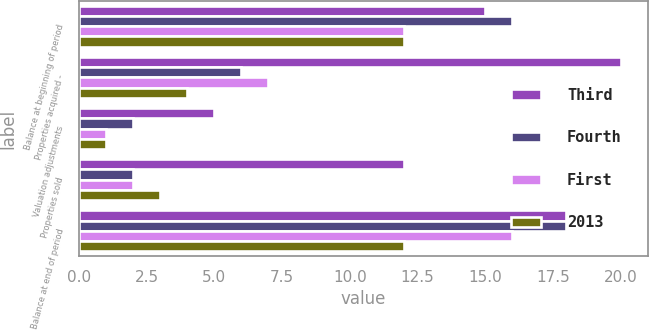Convert chart. <chart><loc_0><loc_0><loc_500><loc_500><stacked_bar_chart><ecel><fcel>Balance at beginning of period<fcel>Properties acquired -<fcel>Valuation adjustments<fcel>Properties sold<fcel>Balance at end of period<nl><fcel>Third<fcel>15<fcel>20<fcel>5<fcel>12<fcel>18<nl><fcel>Fourth<fcel>16<fcel>6<fcel>2<fcel>2<fcel>18<nl><fcel>First<fcel>12<fcel>7<fcel>1<fcel>2<fcel>16<nl><fcel>2013<fcel>12<fcel>4<fcel>1<fcel>3<fcel>12<nl></chart> 